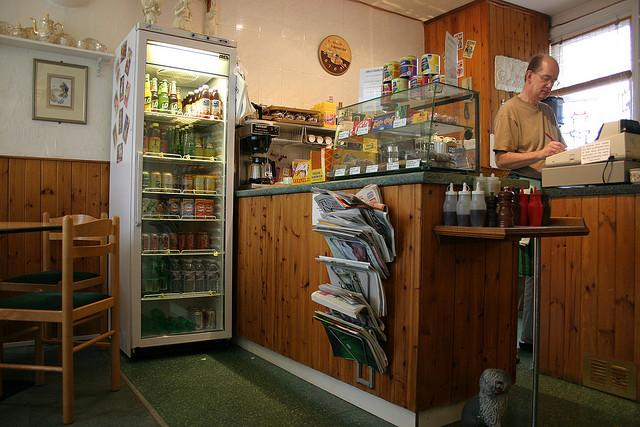What is likely sold here? food 